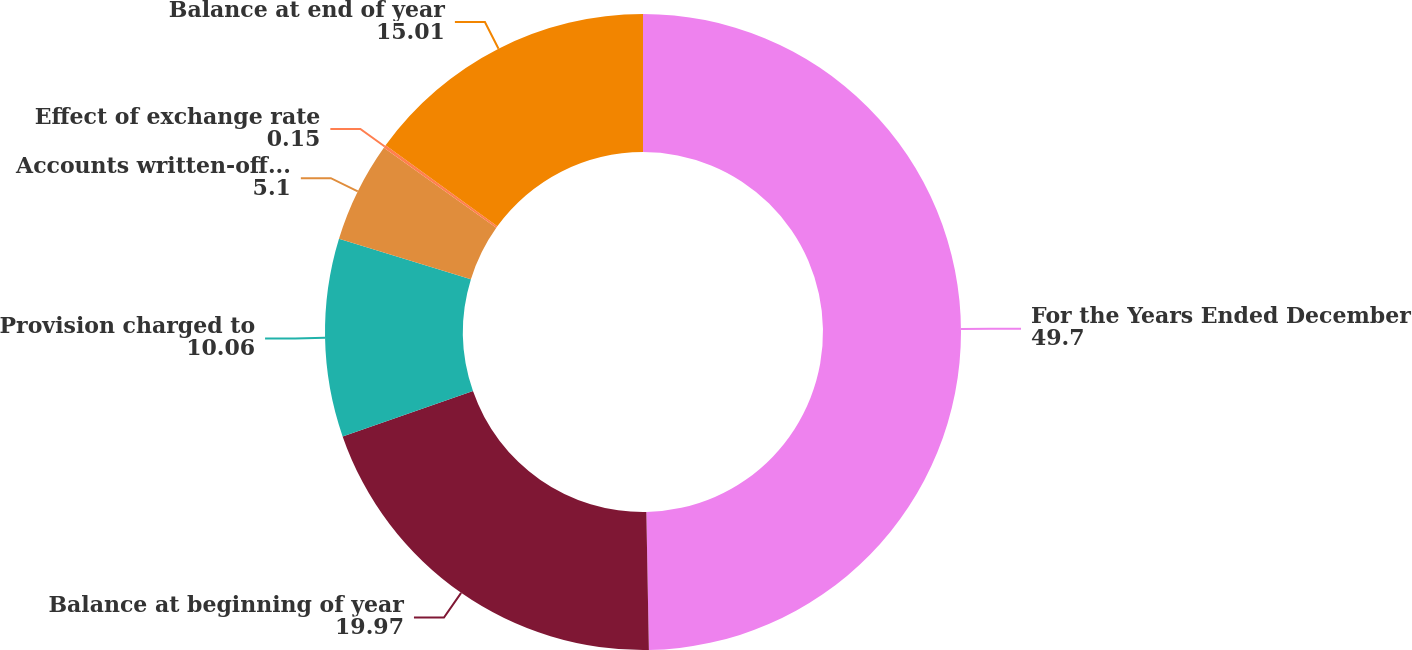Convert chart to OTSL. <chart><loc_0><loc_0><loc_500><loc_500><pie_chart><fcel>For the Years Ended December<fcel>Balance at beginning of year<fcel>Provision charged to<fcel>Accounts written-off net of<fcel>Effect of exchange rate<fcel>Balance at end of year<nl><fcel>49.7%<fcel>19.97%<fcel>10.06%<fcel>5.1%<fcel>0.15%<fcel>15.01%<nl></chart> 